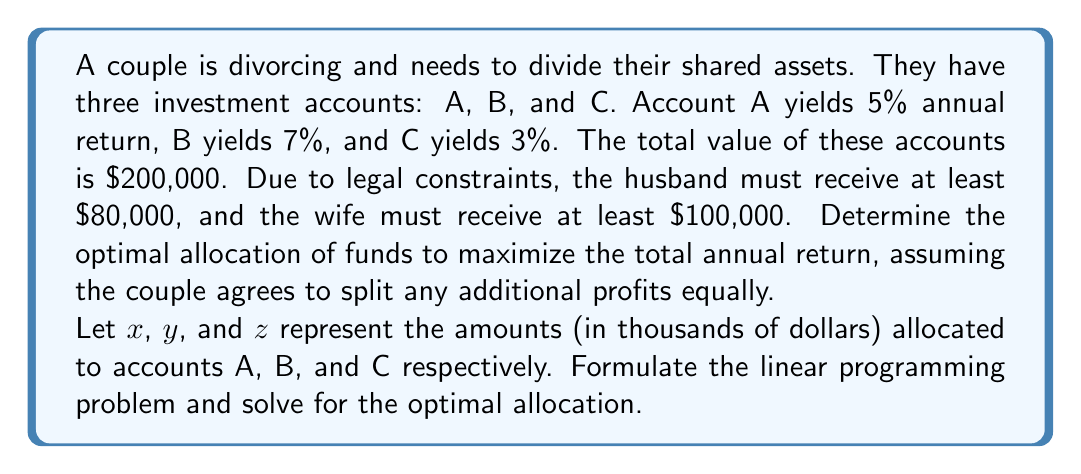Solve this math problem. To solve this problem, we'll follow these steps:

1. Define the objective function:
   We want to maximize the total annual return, which is:
   $$0.05x + 0.07y + 0.03z$$

2. Set up the constraints:
   a) Total amount constraint: $x + y + z = 200$
   b) Husband's minimum: $0.5(x + y + z) \geq 80$
   c) Wife's minimum: $0.5(x + y + z) \geq 100$
   d) Non-negativity: $x, y, z \geq 0$

3. Simplify the constraints:
   b) and c) can be combined into: $0.5(x + y + z) \geq 100$

4. The linear programming problem becomes:
   Maximize: $0.05x + 0.07y + 0.03z$
   Subject to:
   $x + y + z = 200$
   $x + y + z \geq 200$
   $x, y, z \geq 0$

5. Solve the problem:
   To maximize the return, we should allocate as much as possible to the highest-yielding account (B), then to the second-highest (A), and lastly to C if necessary.

   Optimal allocation:
   $y = 200$ (Account B)
   $x = 0$ (Account A)
   $z = 0$ (Account C)

6. Check if this satisfies all constraints:
   It does, as the total is $200,000 and both parties receive at least their minimum amounts.

7. Calculate the maximum annual return:
   $0.07 * 200 = 14$ thousand dollars or $14,000
Answer: Optimal allocation: $200,000 to Account B. Maximum annual return: $14,000. 